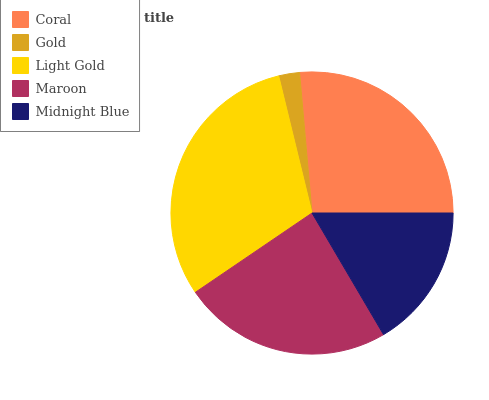Is Gold the minimum?
Answer yes or no. Yes. Is Light Gold the maximum?
Answer yes or no. Yes. Is Light Gold the minimum?
Answer yes or no. No. Is Gold the maximum?
Answer yes or no. No. Is Light Gold greater than Gold?
Answer yes or no. Yes. Is Gold less than Light Gold?
Answer yes or no. Yes. Is Gold greater than Light Gold?
Answer yes or no. No. Is Light Gold less than Gold?
Answer yes or no. No. Is Maroon the high median?
Answer yes or no. Yes. Is Maroon the low median?
Answer yes or no. Yes. Is Midnight Blue the high median?
Answer yes or no. No. Is Coral the low median?
Answer yes or no. No. 